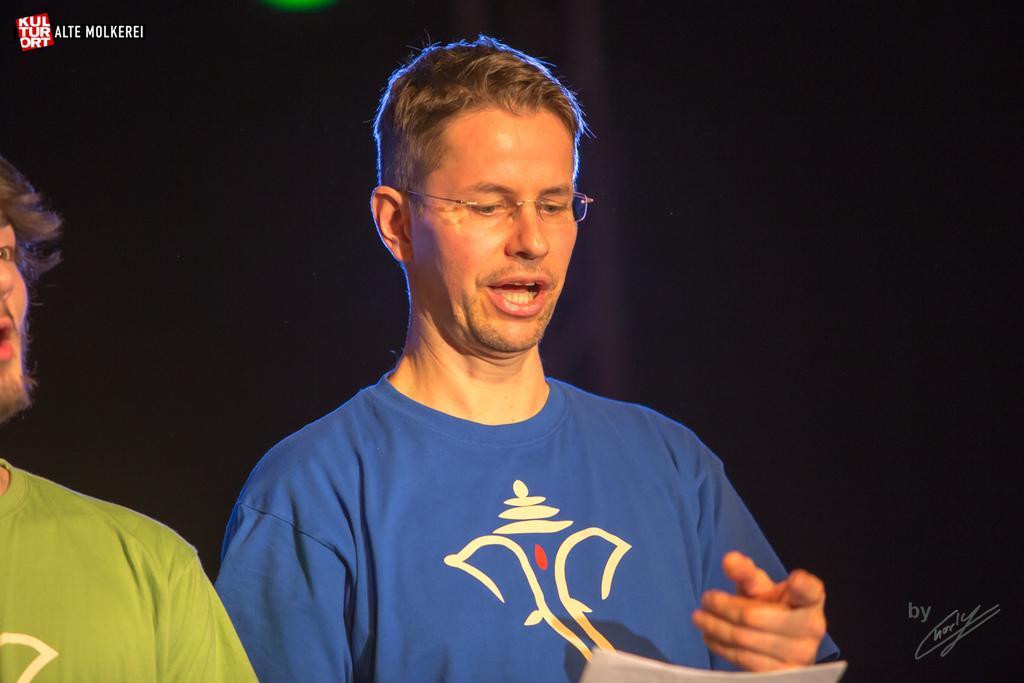How would you summarize this image in a sentence or two? Here we can see two persons and he has spectacles. There is a dark background. 